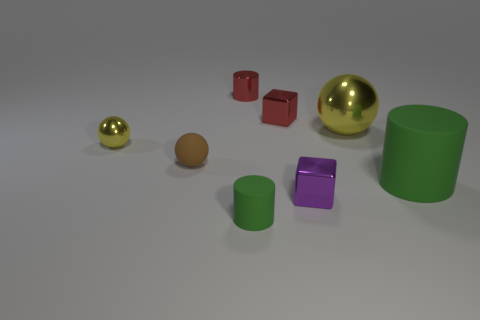Add 2 big green rubber things. How many objects exist? 10 Subtract all balls. How many objects are left? 5 Subtract all big green cylinders. Subtract all tiny brown matte balls. How many objects are left? 6 Add 1 purple cubes. How many purple cubes are left? 2 Add 7 tiny green matte blocks. How many tiny green matte blocks exist? 7 Subtract 1 red cylinders. How many objects are left? 7 